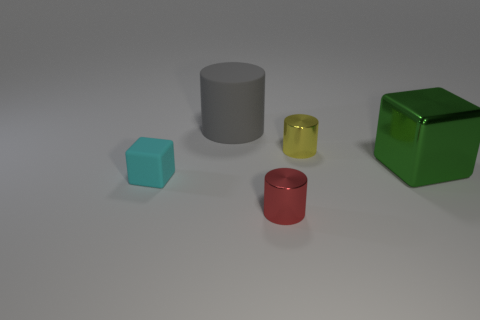There is a rubber object that is behind the large thing that is on the right side of the gray matte cylinder; what size is it?
Your answer should be compact. Large. There is a big green metal object behind the block that is left of the big object in front of the gray rubber cylinder; what is its shape?
Your response must be concise. Cube. The other object that is the same material as the small cyan thing is what color?
Provide a short and direct response. Gray. What color is the small cylinder that is in front of the cube to the left of the big thing right of the red object?
Give a very brief answer. Red. How many cubes are red objects or small objects?
Provide a short and direct response. 1. What is the color of the small cube?
Offer a very short reply. Cyan. What number of objects are cyan objects or big metallic things?
Your answer should be very brief. 2. There is a yellow cylinder that is the same size as the cyan cube; what material is it?
Offer a very short reply. Metal. There is a cylinder left of the small red shiny cylinder; how big is it?
Your answer should be very brief. Large. What material is the gray cylinder?
Offer a terse response. Rubber. 